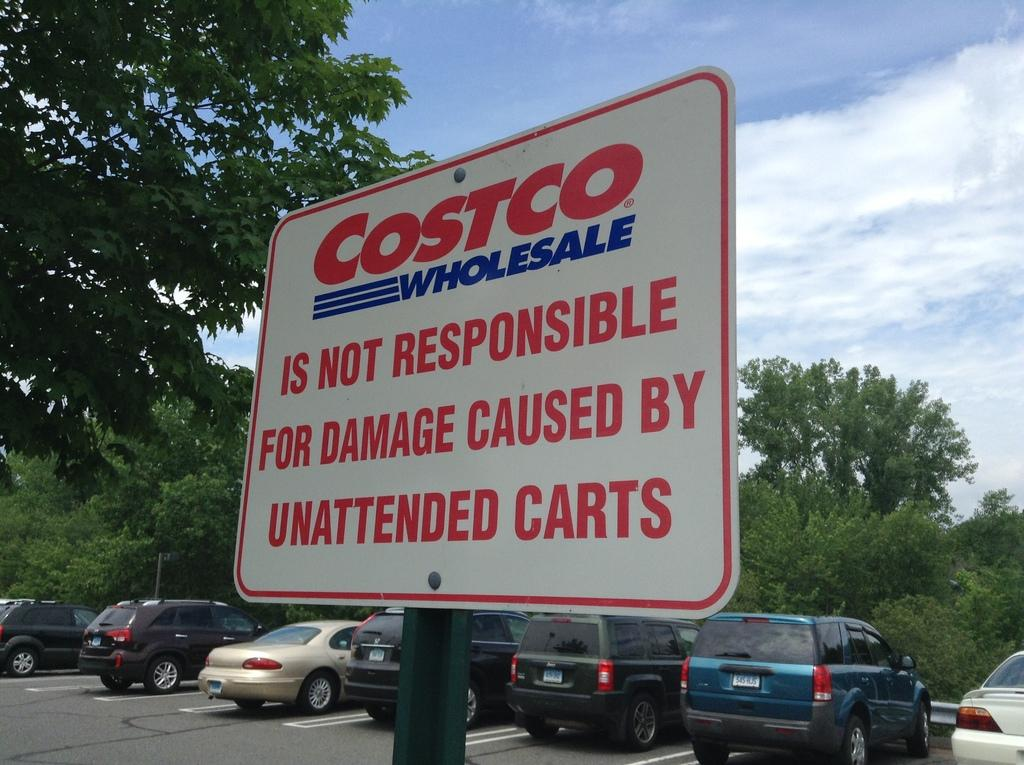What is the main object in the picture? There is a precaution board in the picture. What can be found on the precaution board? There is writing on the precaution board. What can be seen in the background of the picture? Cars parked and trees are visible in the picture. How would you describe the sky in the picture? The sky is clear in the picture. Can you hear the quiet horn in the picture? There is no sound in the picture, so it is not possible to hear a horn, quiet or otherwise. 